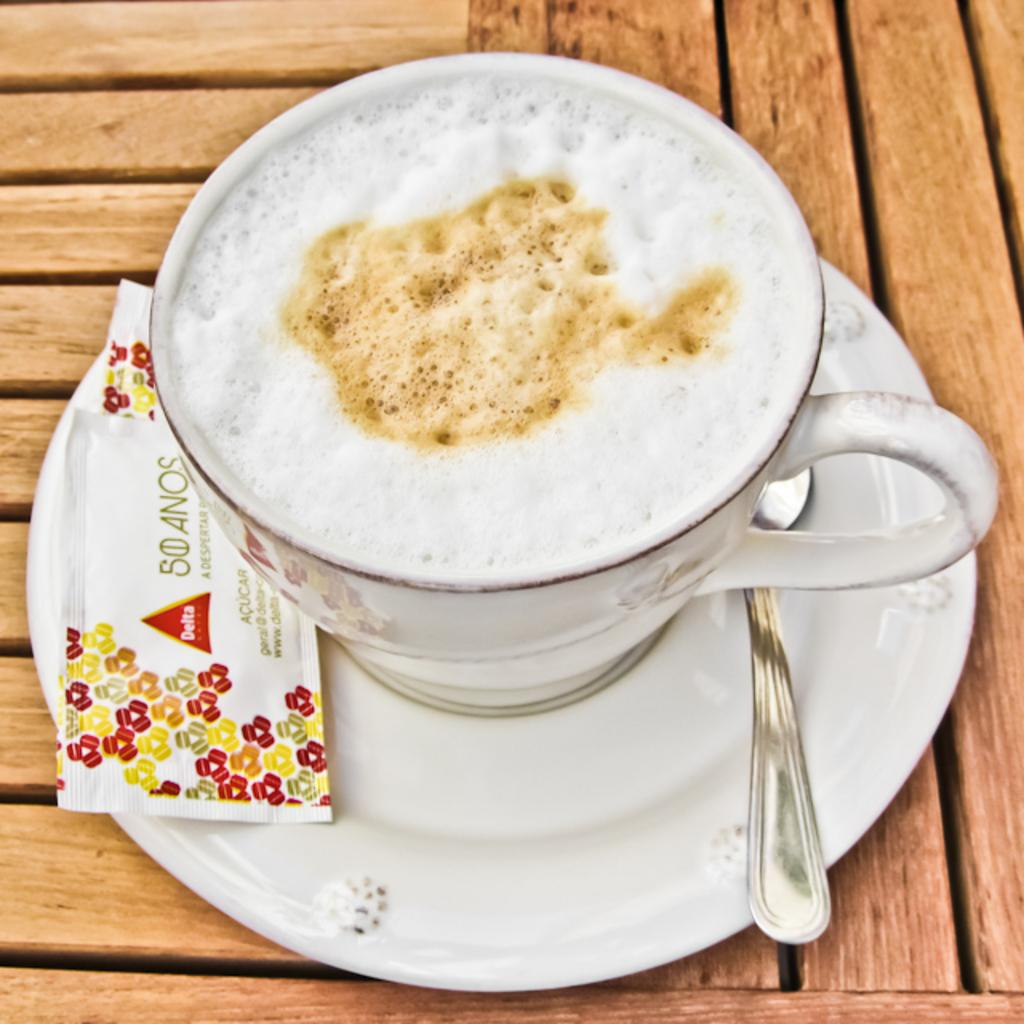What is in the cup that is visible in the image? There is a beverage in a cup in the image. What utensil is present in the image? There is a spoon in the image. What is the saucer used for in the image? The saucer is used to hold the cup in the image. Where are all of these objects placed in the image? All of these objects are placed on a table in the image. What type of steel is used to make the bike in the image? There is no bike present in the image; it only features a beverage, spoon, saucer, and table. 